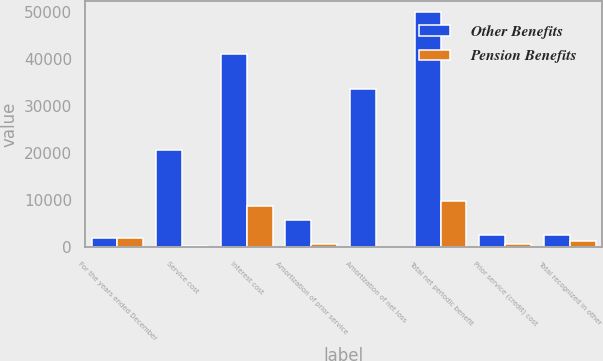Convert chart to OTSL. <chart><loc_0><loc_0><loc_500><loc_500><stacked_bar_chart><ecel><fcel>For the years ended December<fcel>Service cost<fcel>Interest cost<fcel>Amortization of prior service<fcel>Amortization of net loss<fcel>Total net periodic benefit<fcel>Prior service (credit) cost<fcel>Total recognized in other<nl><fcel>Other Benefits<fcel>2017<fcel>20657<fcel>40996<fcel>5822<fcel>33648<fcel>49841<fcel>2650<fcel>2650<nl><fcel>Pension Benefits<fcel>2017<fcel>263<fcel>8837<fcel>748<fcel>1<fcel>9847<fcel>744<fcel>1395<nl></chart> 